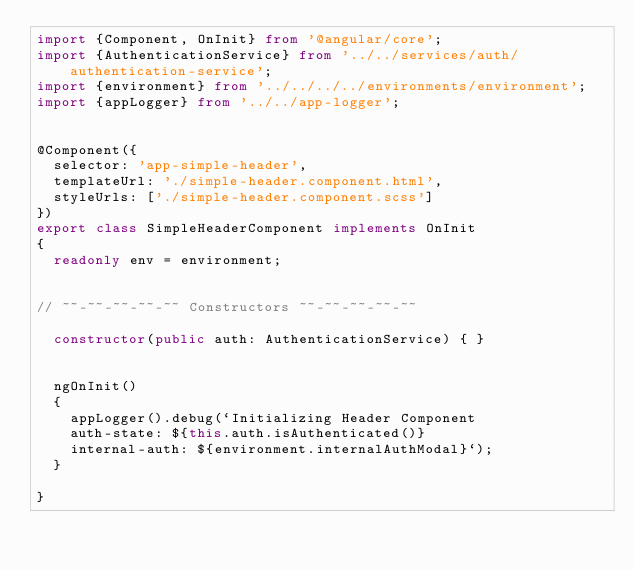<code> <loc_0><loc_0><loc_500><loc_500><_TypeScript_>import {Component, OnInit} from '@angular/core';
import {AuthenticationService} from '../../services/auth/authentication-service';
import {environment} from '../../../../environments/environment';
import {appLogger} from '../../app-logger';


@Component({
  selector: 'app-simple-header',
  templateUrl: './simple-header.component.html',
  styleUrls: ['./simple-header.component.scss']
})
export class SimpleHeaderComponent implements OnInit
{
  readonly env = environment;


// ~~-~~-~~-~~-~~ Constructors ~~-~~-~~-~~-~~

  constructor(public auth: AuthenticationService) { }


  ngOnInit()
  {
    appLogger().debug(`Initializing Header Component
    auth-state: ${this.auth.isAuthenticated()}
    internal-auth: ${environment.internalAuthModal}`);
  }

}
</code> 